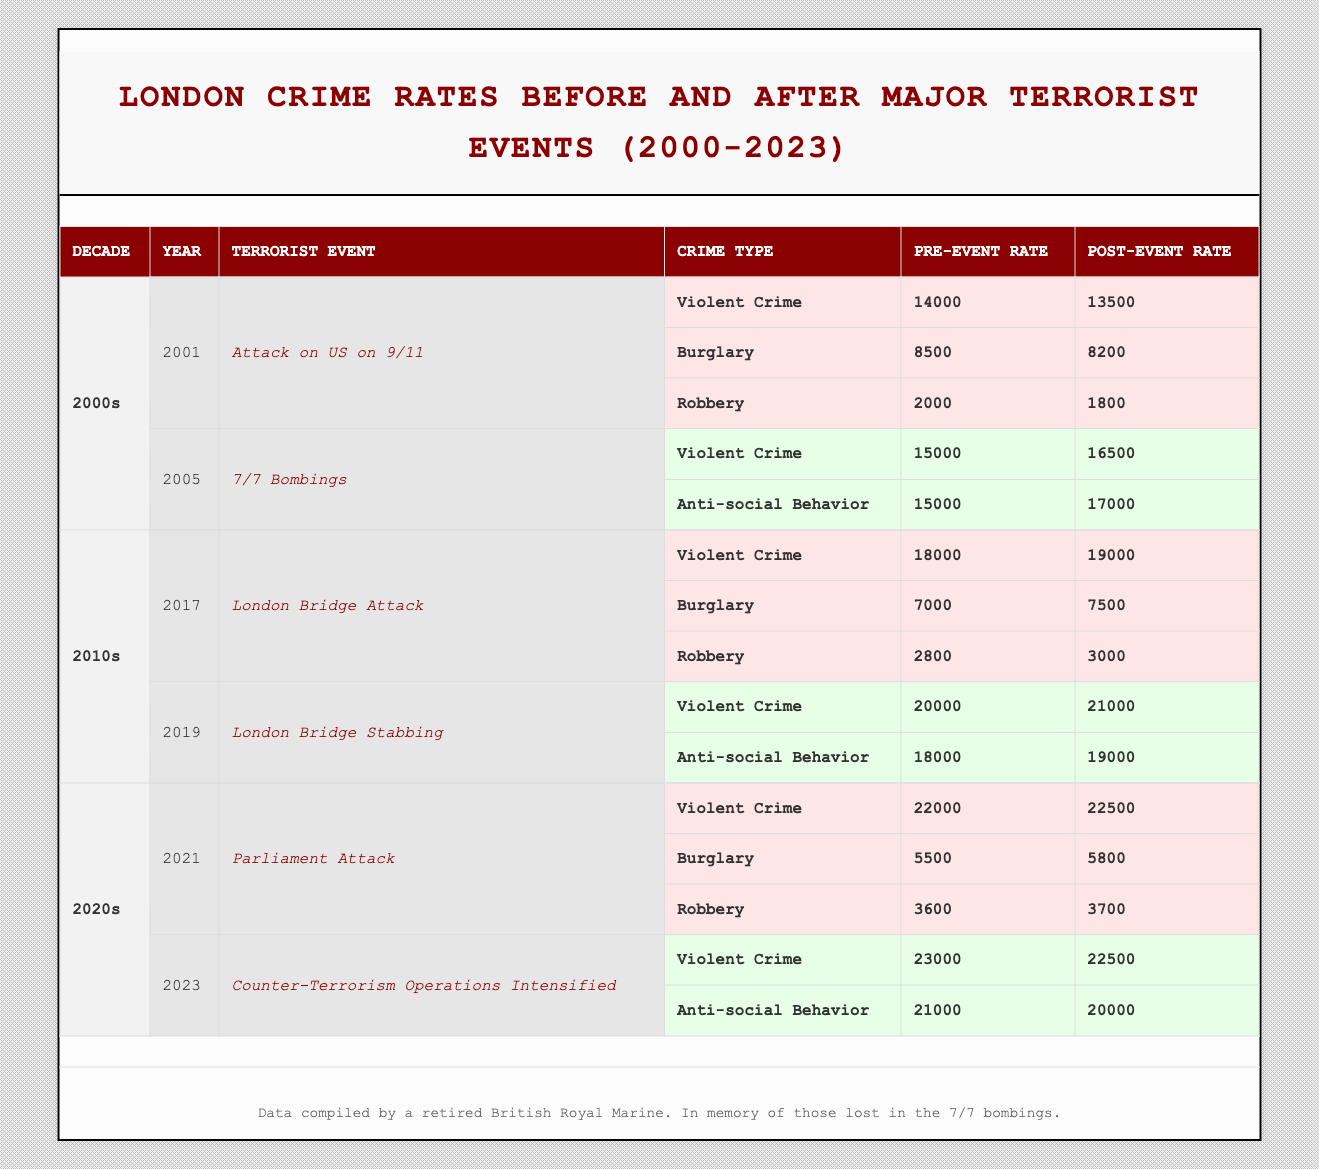What was the Pre-Event Crime Rate for Violent Crime in 2005? According to the table, the Pre-Event Crime Rate for Violent Crime in 2005, during the year of the 7/7 Bombings, is listed as 15000.
Answer: 15000 What is the difference in Burglary rates before and after the 2019 terrorist event? The Pre-Event rate for Burglary in 2019 is 6000 and the Post-Event rate is 6800. To find the difference, subtract the Pre-Event rate from the Post-Event rate: 6800 - 6000 = 800.
Answer: 800 Did the Violent Crime rate increase after the London Bridge Attack in 2017? The Pre-Event rate for Violent Crime in 2017 was 18000, and the Post-Event rate was 19000. Since 19000 is greater than 18000, it confirms that the rate did increase.
Answer: Yes What was the highest recorded Pre-Event rate of Anti-social Behavior in the table? Looking through the data, the Pre-Event rate for Anti-social Behavior in 2005 was 15000, which is the highest value compared to all other years listed in the table.
Answer: 15000 What is the average Post-Event rate of Robbery across all incidents listed? The Post-Event Robbery rates are 1800 (2001), 2400 (2005), 3000 (2017), 3400 (2019), 3700 (2021), and 3900 (2023). To find the average, sum these values: 1800 + 2400 + 3000 + 3400 + 3700 + 3900 = 18200. Then, divide by the number of events (6): 18200 / 6 = 3033.33.
Answer: 3033.33 What was the lowest recorded Burglary rate Post-Event and in which year? The table shows the Post-Event Burglary rates as follows: 8200 (2001), 9500 (2005), 7500 (2017), 6800 (2019), 5800 (2021), and 4500 (2023). The lowest value is 4500 in 2023.
Answer: 4500 in 2023 